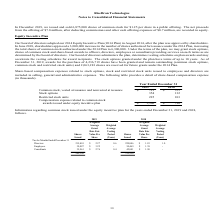From Ricebran Technologies's financial document, What are the respective values of stock options in 2018 and 2019? The document shows two values: 132 and 354 (in thousands). From the document: "Stock options 354 132 Stock options 354 132..." Also, What are the respective values of restricted stock units  in 2018 and 2019? The document shows two values: 103 and 225 (in thousands). From the document: "Restricted stock units 225 103 Restricted stock units 225 103..." Also, What are the respective values of common stock in 2018 and 2019? The document shows two values: $555 and $721 (in thousands). From the document: "ock, vested at issuance and nonvested at issuance 721 $ 555 $ ested at issuance and nonvested at issuance 721 $ 555 $..." Also, can you calculate: What is the change in the common stock value between 2018 and 2019? Based on the calculation: 721 - 555 , the result is 166 (in thousands). This is based on the information: "ock, vested at issuance and nonvested at issuance 721 $ 555 $ ested at issuance and nonvested at issuance 721 $ 555 $..." The key data points involved are: 555, 721. Also, can you calculate: What is the total value of stock options in 2018 and 2019? Based on the calculation: 354 + 132 , the result is 486 (in thousands). This is based on the information: "Stock options 354 132 Stock options 354 132..." The key data points involved are: 132, 354. Also, can you calculate: What is the average value of stock options in 2018 and 2019? To answer this question, I need to perform calculations using the financial data. The calculation is: (354 + 132)/2 , which equals 243 (in thousands). This is based on the information: "Stock options 354 132 Stock options 354 132..." The key data points involved are: 132, 354. 